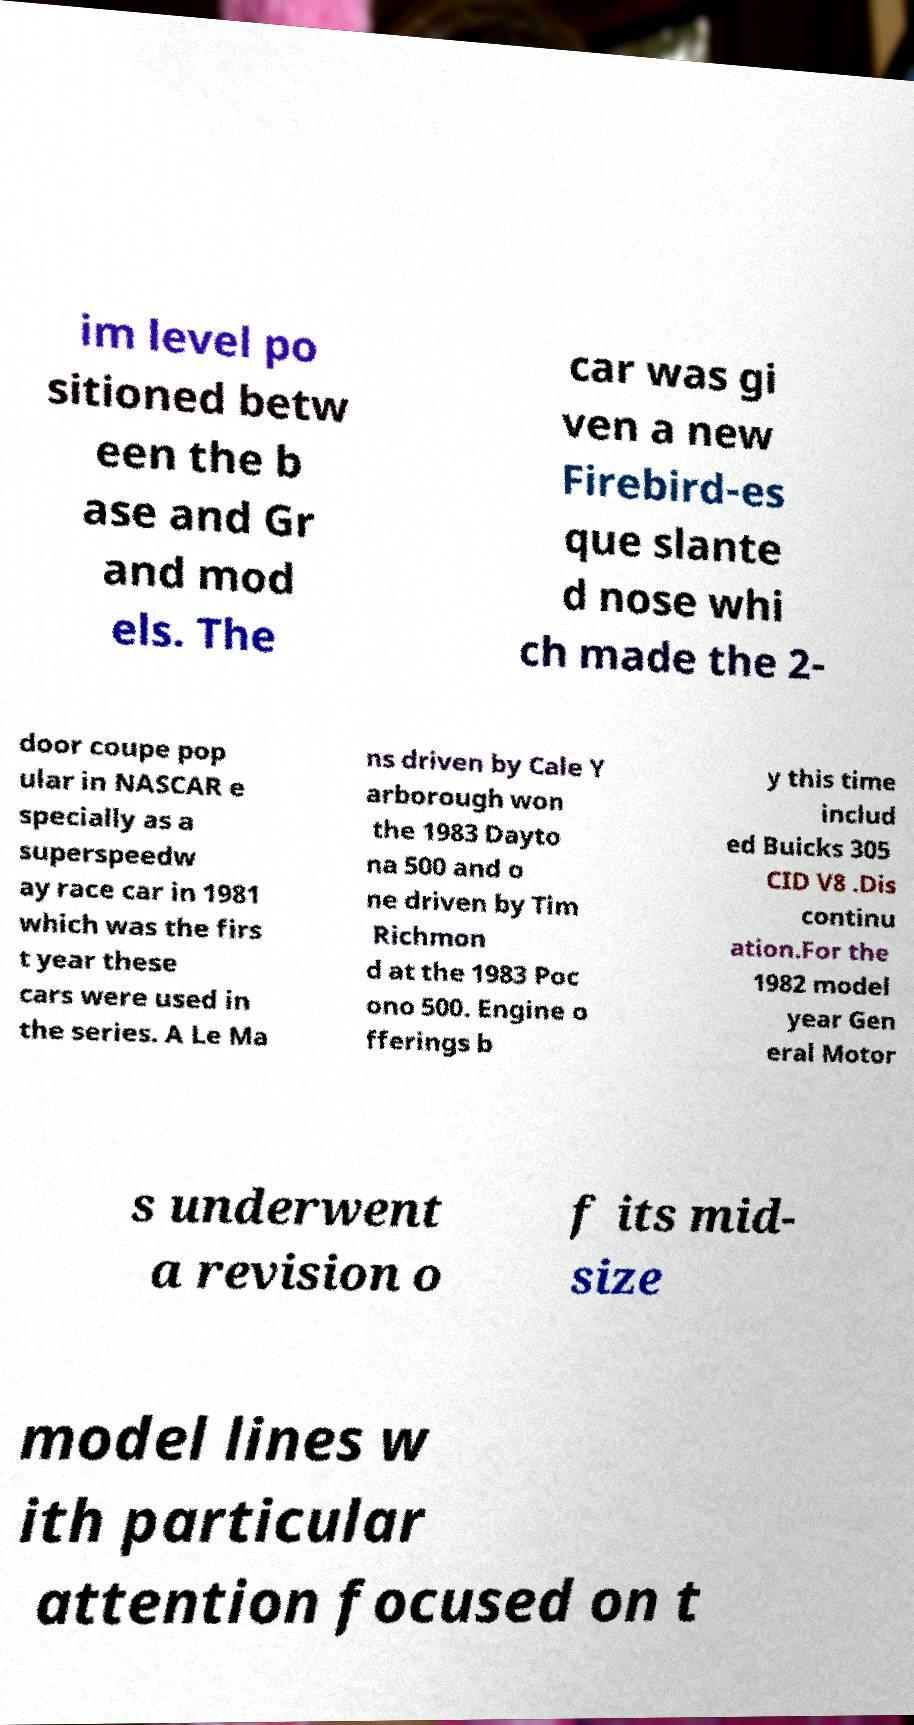Can you accurately transcribe the text from the provided image for me? im level po sitioned betw een the b ase and Gr and mod els. The car was gi ven a new Firebird-es que slante d nose whi ch made the 2- door coupe pop ular in NASCAR e specially as a superspeedw ay race car in 1981 which was the firs t year these cars were used in the series. A Le Ma ns driven by Cale Y arborough won the 1983 Dayto na 500 and o ne driven by Tim Richmon d at the 1983 Poc ono 500. Engine o fferings b y this time includ ed Buicks 305 CID V8 .Dis continu ation.For the 1982 model year Gen eral Motor s underwent a revision o f its mid- size model lines w ith particular attention focused on t 